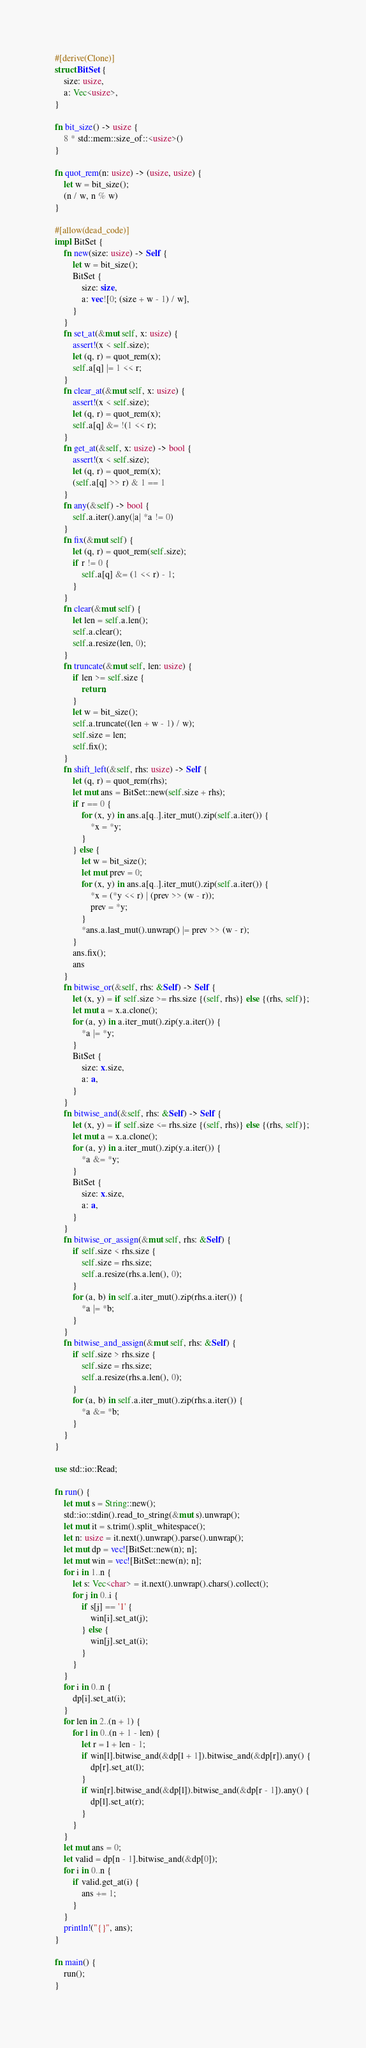<code> <loc_0><loc_0><loc_500><loc_500><_Rust_>#[derive(Clone)]
struct BitSet {
    size: usize,
    a: Vec<usize>,
}

fn bit_size() -> usize {
    8 * std::mem::size_of::<usize>()
}

fn quot_rem(n: usize) -> (usize, usize) {
    let w = bit_size();
    (n / w, n % w)
}

#[allow(dead_code)]
impl BitSet {
    fn new(size: usize) -> Self {
        let w = bit_size();
        BitSet {
            size: size,
            a: vec![0; (size + w - 1) / w],
        }
    }
    fn set_at(&mut self, x: usize) {
        assert!(x < self.size);
        let (q, r) = quot_rem(x);
        self.a[q] |= 1 << r;
    }
    fn clear_at(&mut self, x: usize) {
        assert!(x < self.size);
        let (q, r) = quot_rem(x);
        self.a[q] &= !(1 << r);
    }
    fn get_at(&self, x: usize) -> bool {
        assert!(x < self.size);
        let (q, r) = quot_rem(x);
        (self.a[q] >> r) & 1 == 1
    }
    fn any(&self) -> bool {
        self.a.iter().any(|a| *a != 0)
    }
    fn fix(&mut self) {
        let (q, r) = quot_rem(self.size);
        if r != 0 {
            self.a[q] &= (1 << r) - 1;
        }
    }
    fn clear(&mut self) {
        let len = self.a.len();
        self.a.clear();
        self.a.resize(len, 0);
    }
    fn truncate(&mut self, len: usize) {
        if len >= self.size {
            return;
        }
        let w = bit_size();
        self.a.truncate((len + w - 1) / w);
        self.size = len;
        self.fix();
    }
    fn shift_left(&self, rhs: usize) -> Self {
        let (q, r) = quot_rem(rhs);
        let mut ans = BitSet::new(self.size + rhs);
        if r == 0 {
            for (x, y) in ans.a[q..].iter_mut().zip(self.a.iter()) {
                *x = *y;
            }
        } else {
            let w = bit_size();
            let mut prev = 0;
            for (x, y) in ans.a[q..].iter_mut().zip(self.a.iter()) {
                *x = (*y << r) | (prev >> (w - r));
                prev = *y;
            }
            *ans.a.last_mut().unwrap() |= prev >> (w - r);
        }
        ans.fix();
        ans
    }
    fn bitwise_or(&self, rhs: &Self) -> Self {
        let (x, y) = if self.size >= rhs.size {(self, rhs)} else {(rhs, self)};
        let mut a = x.a.clone();
        for (a, y) in a.iter_mut().zip(y.a.iter()) {
            *a |= *y;
        }
        BitSet {
            size: x.size,
            a: a,
        }
    }
    fn bitwise_and(&self, rhs: &Self) -> Self {
        let (x, y) = if self.size <= rhs.size {(self, rhs)} else {(rhs, self)};
        let mut a = x.a.clone();
        for (a, y) in a.iter_mut().zip(y.a.iter()) {
            *a &= *y;
        }
        BitSet {
            size: x.size,
            a: a,
        }
    }
    fn bitwise_or_assign(&mut self, rhs: &Self) {
        if self.size < rhs.size {
            self.size = rhs.size;
            self.a.resize(rhs.a.len(), 0);
        }
        for (a, b) in self.a.iter_mut().zip(rhs.a.iter()) {
            *a |= *b;
        }
    }
    fn bitwise_and_assign(&mut self, rhs: &Self) {
        if self.size > rhs.size {
            self.size = rhs.size;
            self.a.resize(rhs.a.len(), 0);
        }
        for (a, b) in self.a.iter_mut().zip(rhs.a.iter()) {
            *a &= *b;
        }
    }
}

use std::io::Read;

fn run() {
    let mut s = String::new();
    std::io::stdin().read_to_string(&mut s).unwrap();
    let mut it = s.trim().split_whitespace();
    let n: usize = it.next().unwrap().parse().unwrap();
    let mut dp = vec![BitSet::new(n); n];
    let mut win = vec![BitSet::new(n); n];
    for i in 1..n {
        let s: Vec<char> = it.next().unwrap().chars().collect();
        for j in 0..i {
            if s[j] == '1' {
                win[i].set_at(j);
            } else {
                win[j].set_at(i);
            }
        }
    }
    for i in 0..n {
        dp[i].set_at(i);
    }
    for len in 2..(n + 1) {
        for l in 0..(n + 1 - len) {
            let r = l + len - 1;
            if win[l].bitwise_and(&dp[l + 1]).bitwise_and(&dp[r]).any() {
                dp[r].set_at(l);
            }
            if win[r].bitwise_and(&dp[l]).bitwise_and(&dp[r - 1]).any() {
                dp[l].set_at(r);
            }
        }
    }
    let mut ans = 0;
    let valid = dp[n - 1].bitwise_and(&dp[0]);
    for i in 0..n {
        if valid.get_at(i) {
            ans += 1;
        }
    }
    println!("{}", ans);
}

fn main() {
    run();
}
</code> 